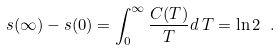<formula> <loc_0><loc_0><loc_500><loc_500>s ( \infty ) - s ( 0 ) = \int _ { 0 } ^ { \infty } \frac { C ( T ) } { T } d \, T = \ln 2 \ .</formula> 